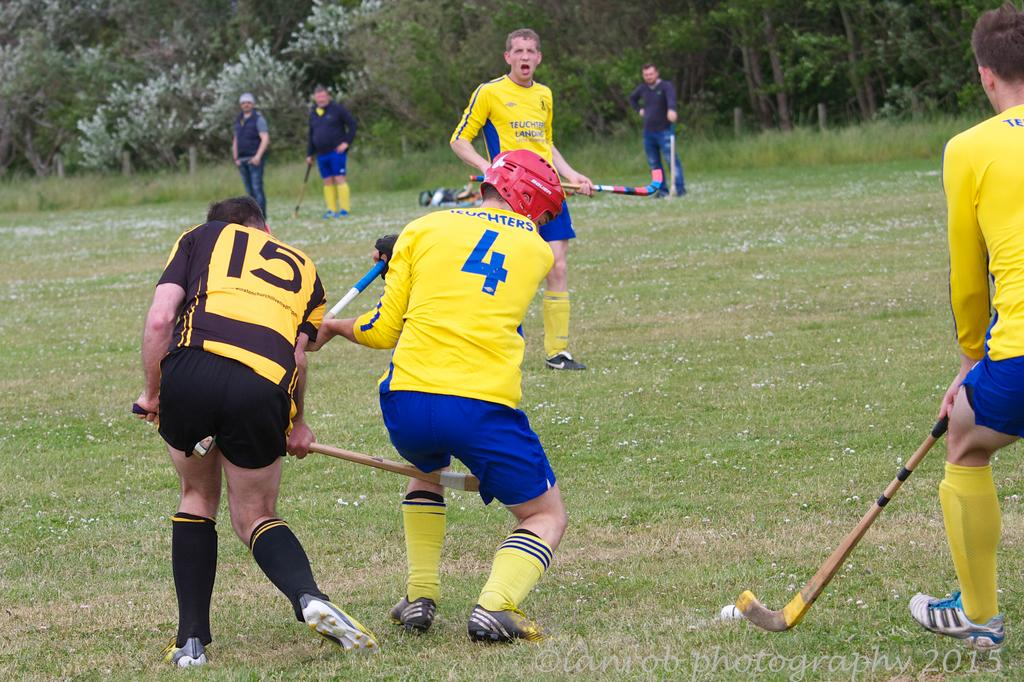Provide a one-sentence caption for the provided image. The player wearing black shorts is number 15. 